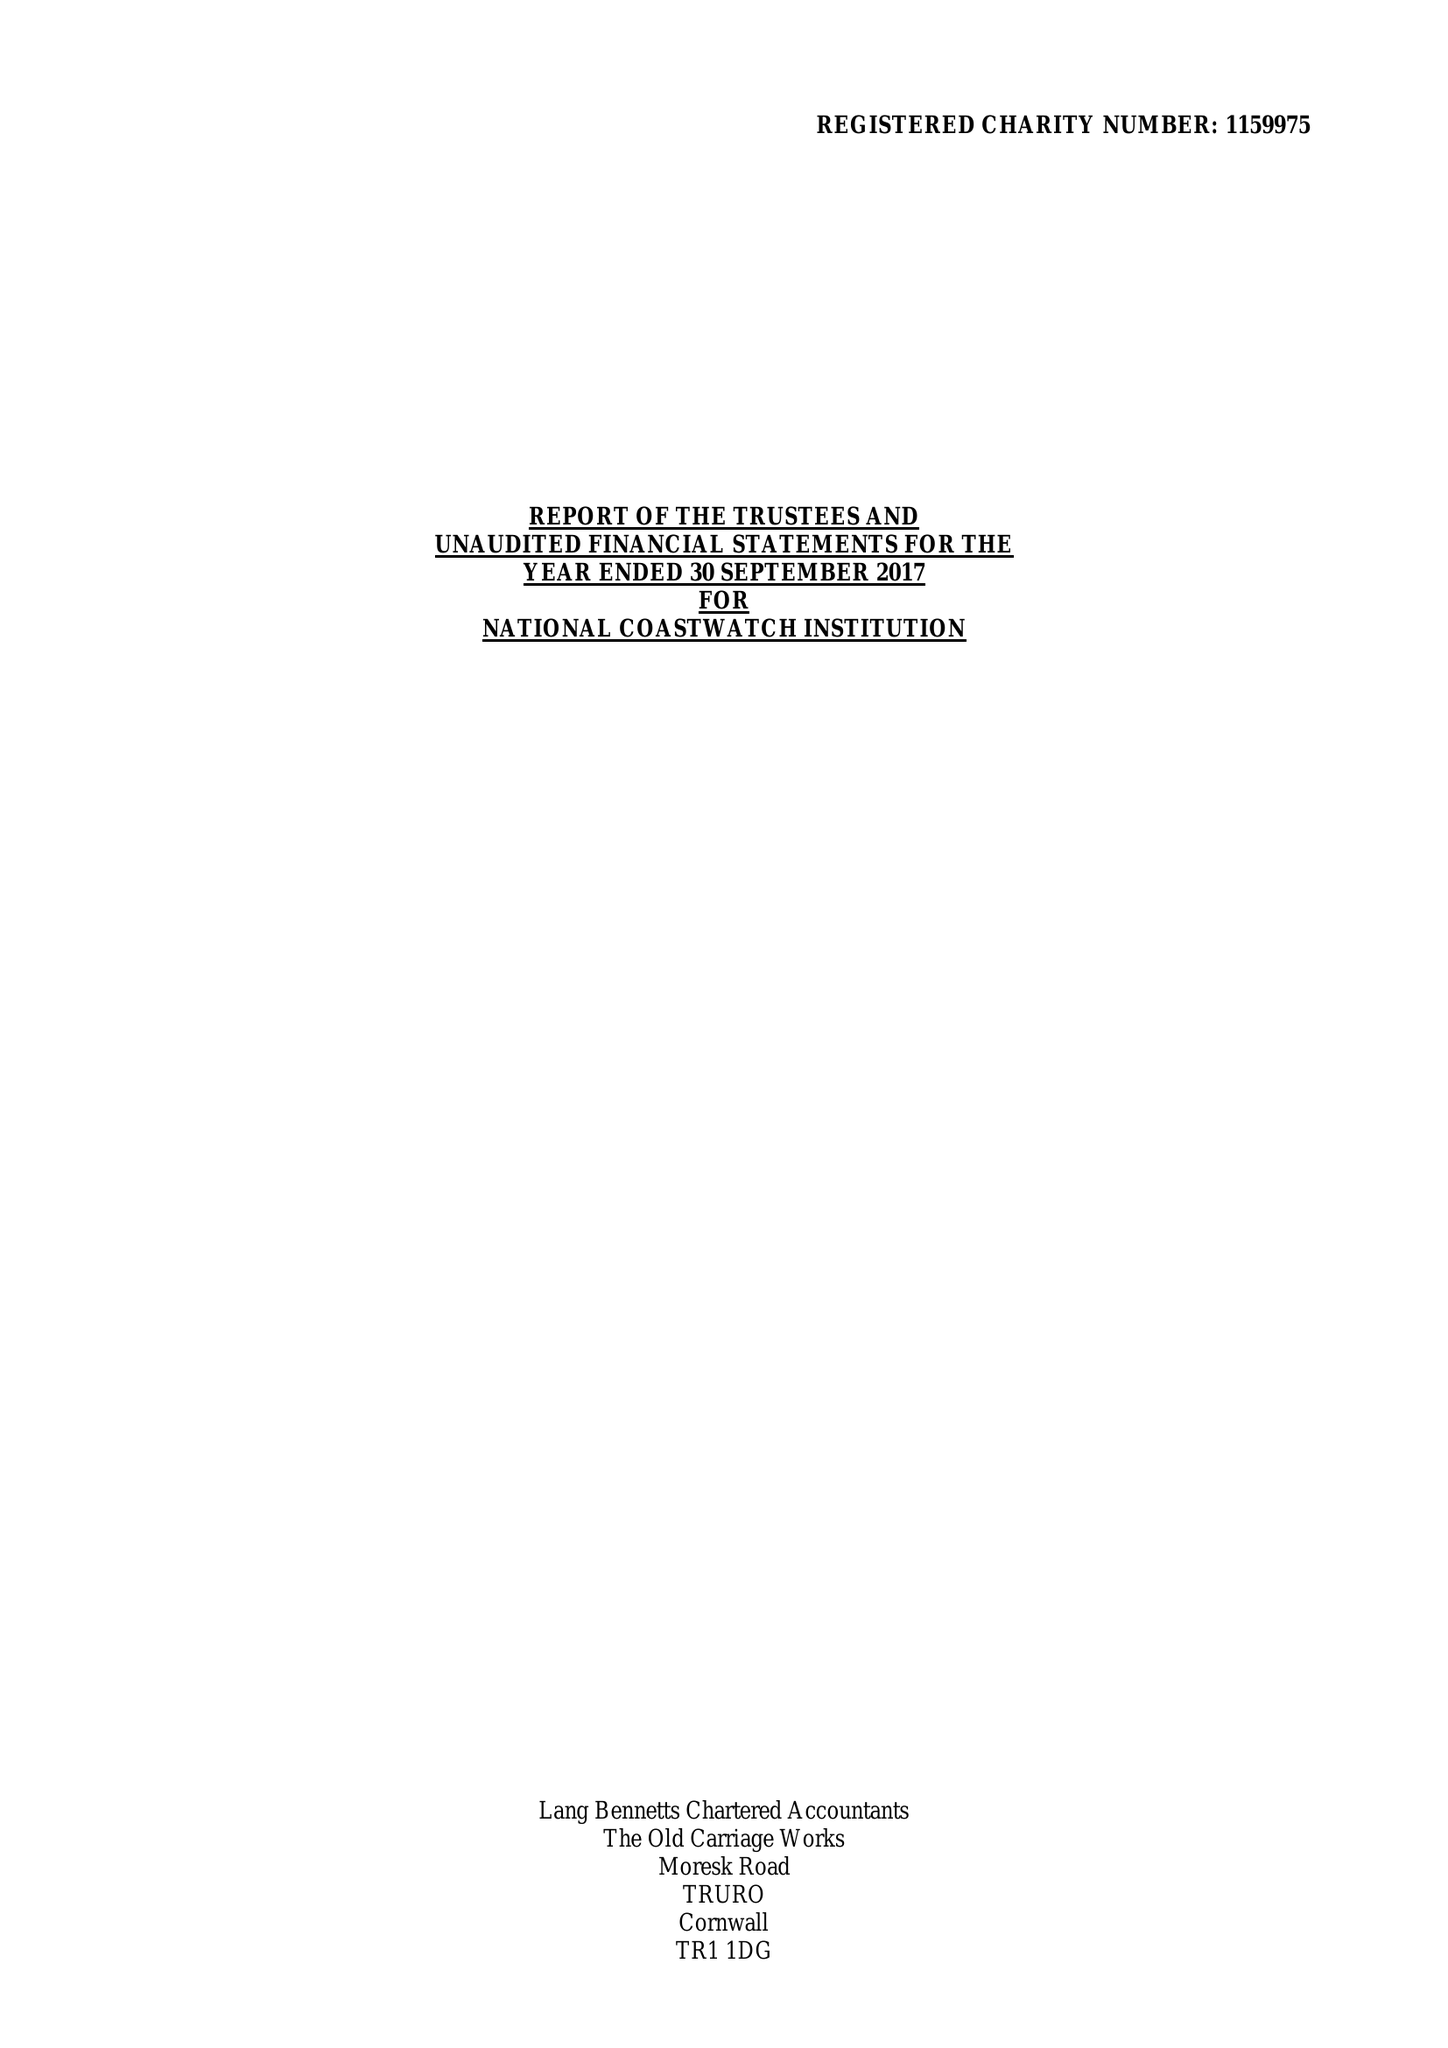What is the value for the address__street_line?
Answer the question using a single word or phrase. 17 DEAN STREET 